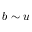Convert formula to latex. <formula><loc_0><loc_0><loc_500><loc_500>b \sim u</formula> 